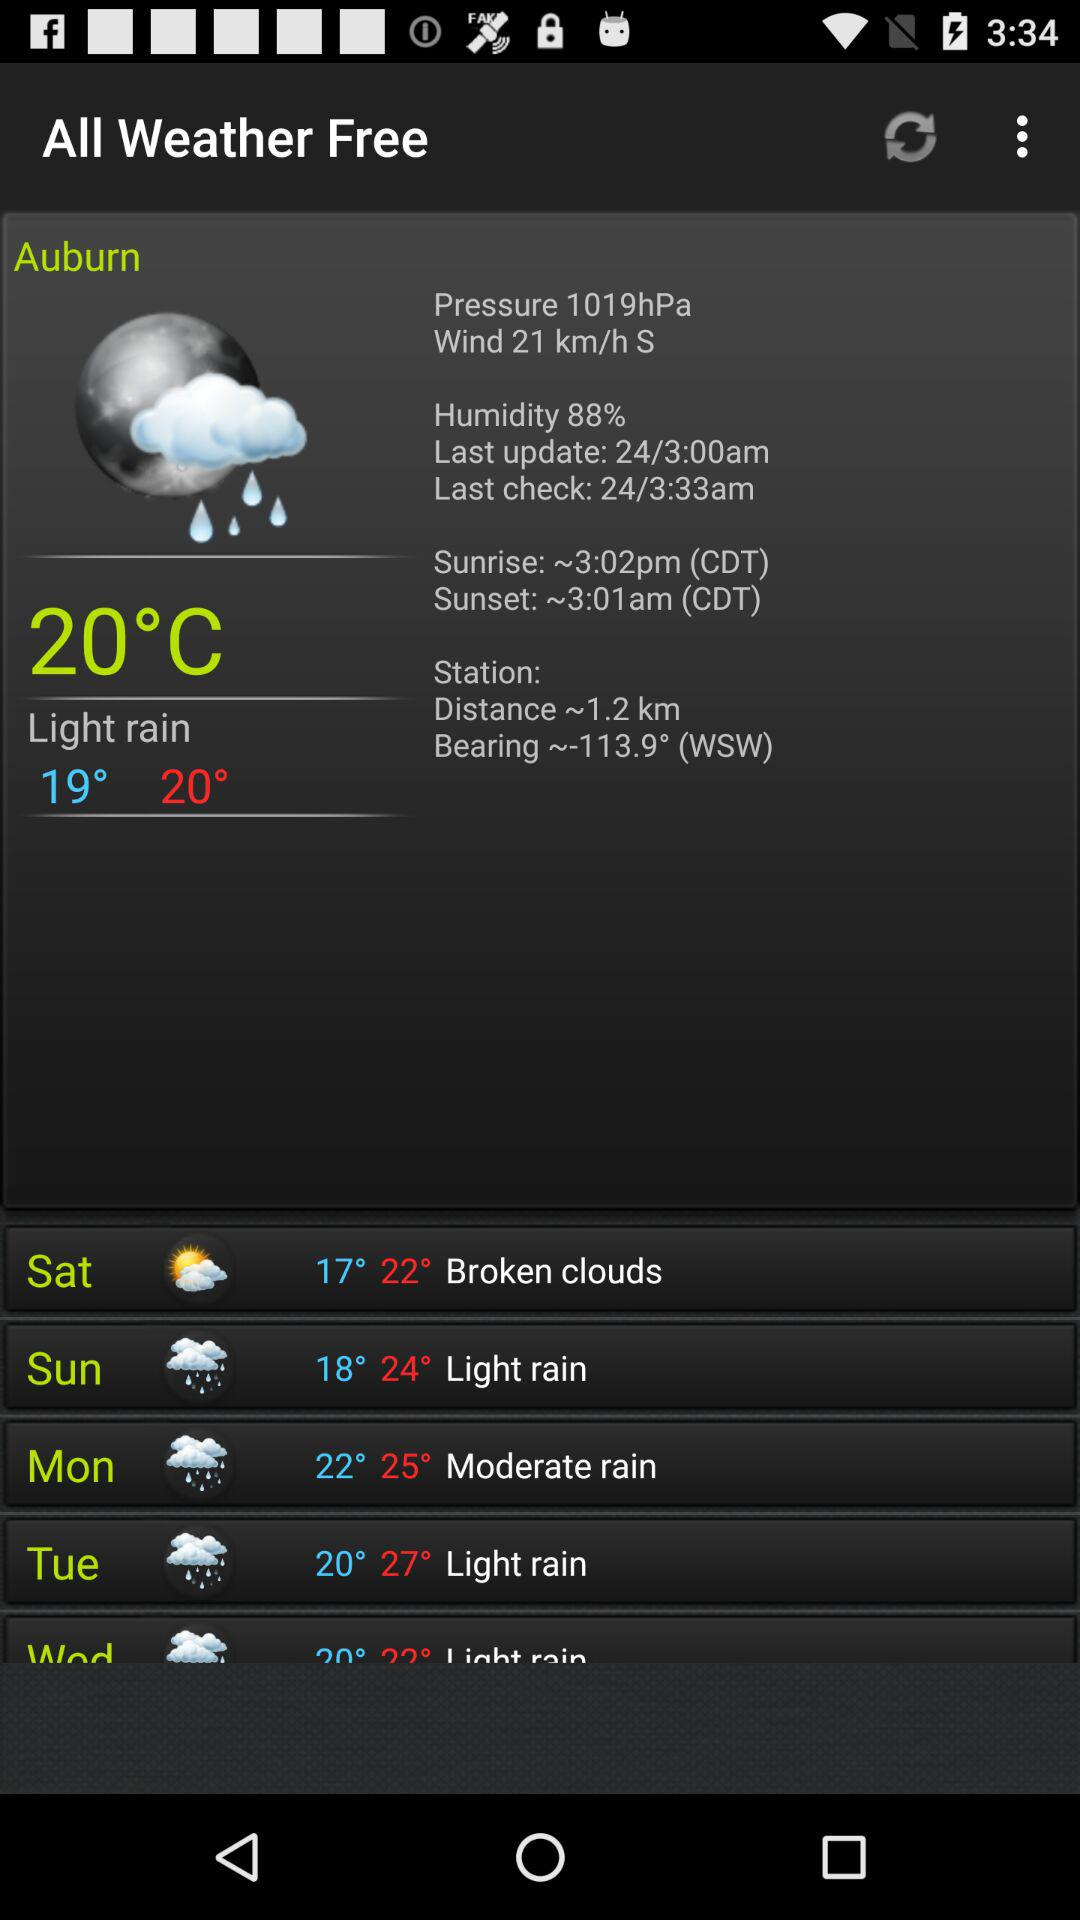What is the sunrise time? The sunrise time is 3:02 PM (CDT). 